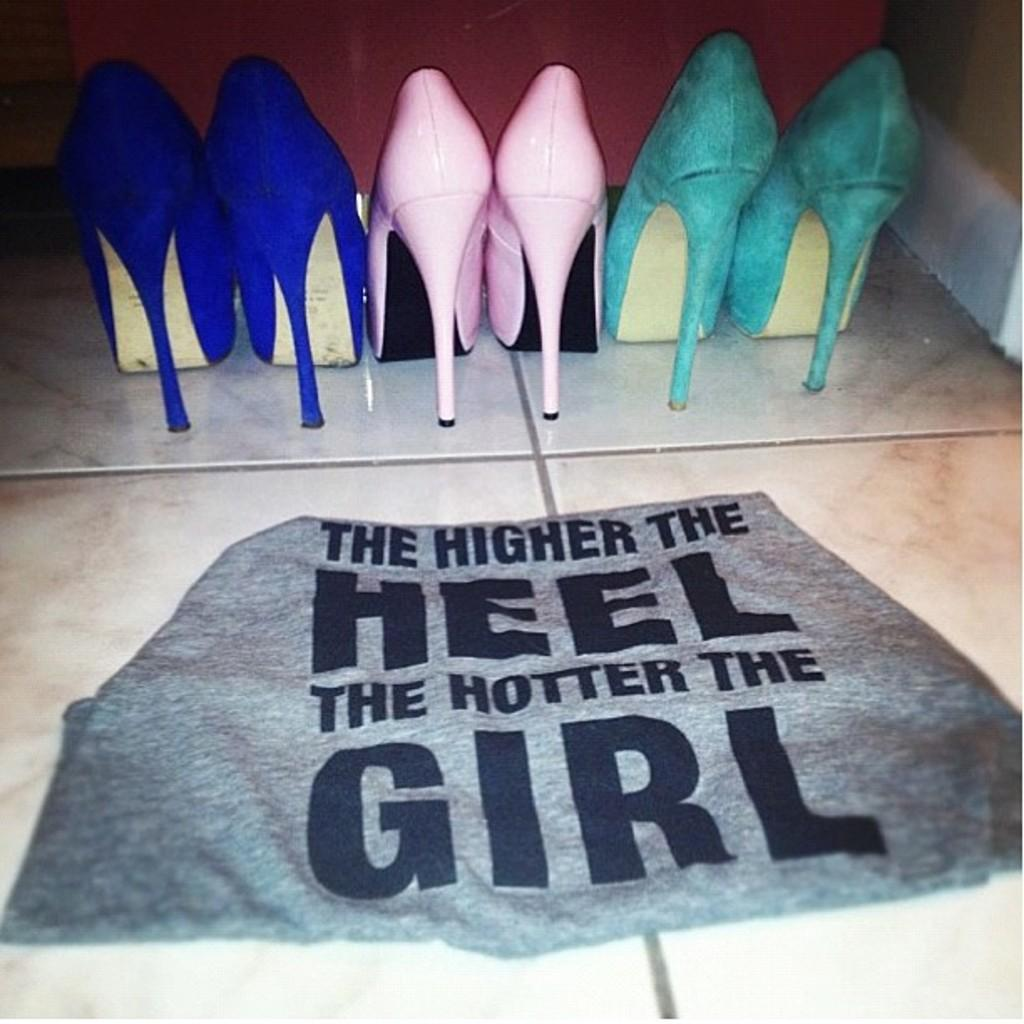How many pairs of heels are visible in the image? There are three pairs of heels in the image. What is on the floor in the image? There is a cloth on the floor in the image. What shape is the quiver in the image? There is no quiver present in the image. 